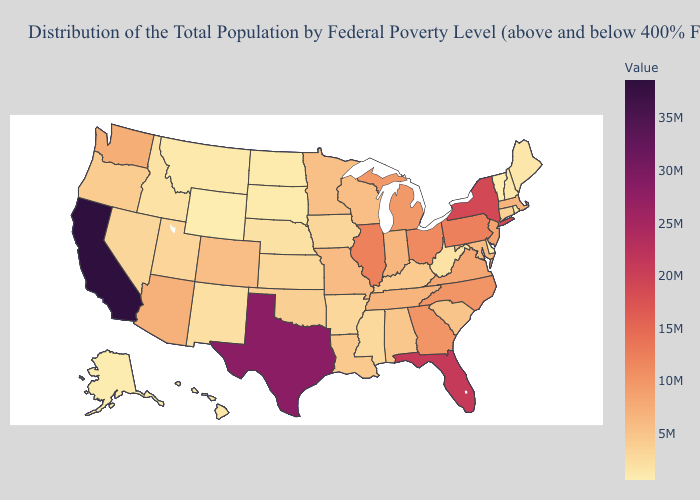Does Arkansas have the highest value in the South?
Short answer required. No. Which states have the highest value in the USA?
Short answer required. California. Does the map have missing data?
Be succinct. No. 